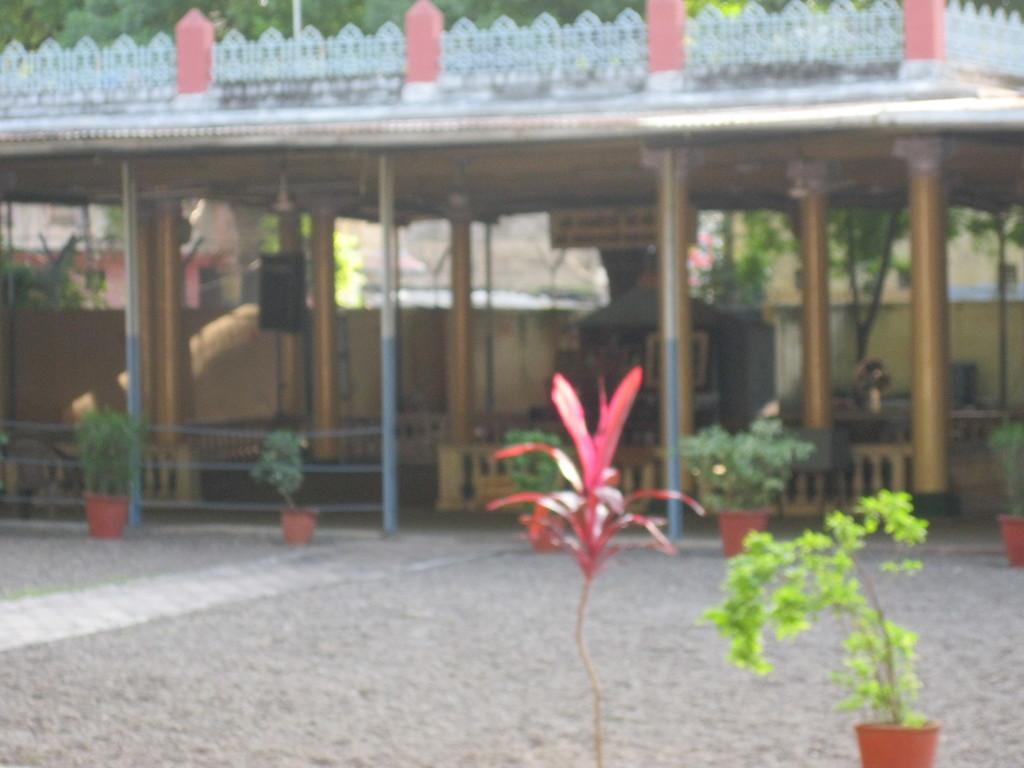In one or two sentences, can you explain what this image depicts? In this image we can see the pillars, shed, plants, fence and we can also see the walls. 